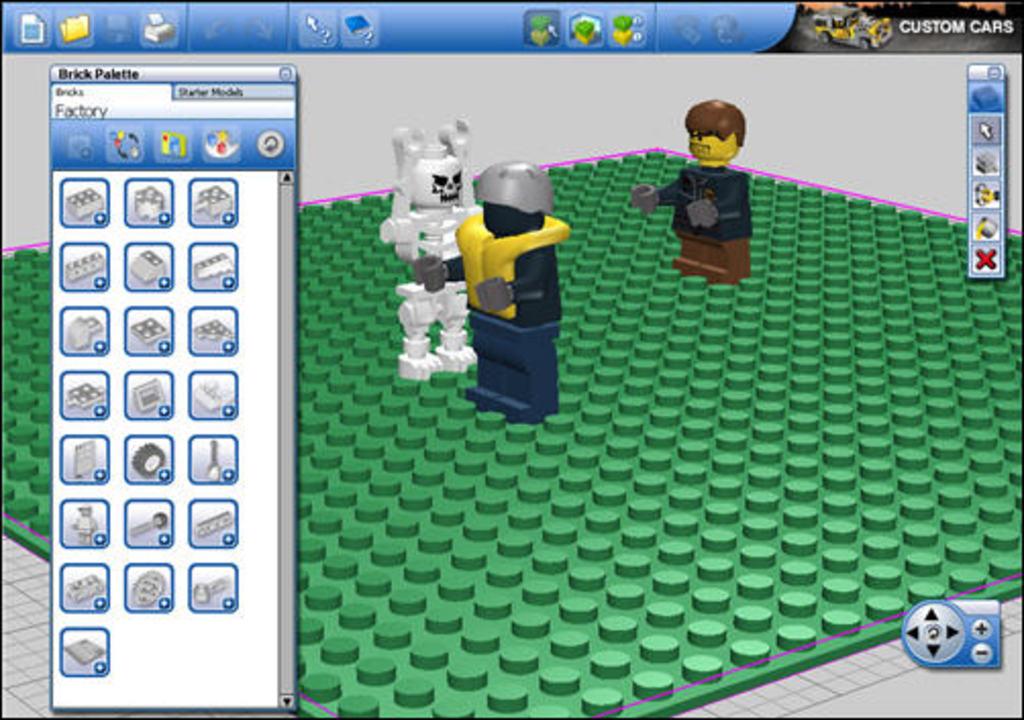Are they on the brick palette screen?
Give a very brief answer. Yes. What is the word at the top of all the icons?
Give a very brief answer. Factory. 